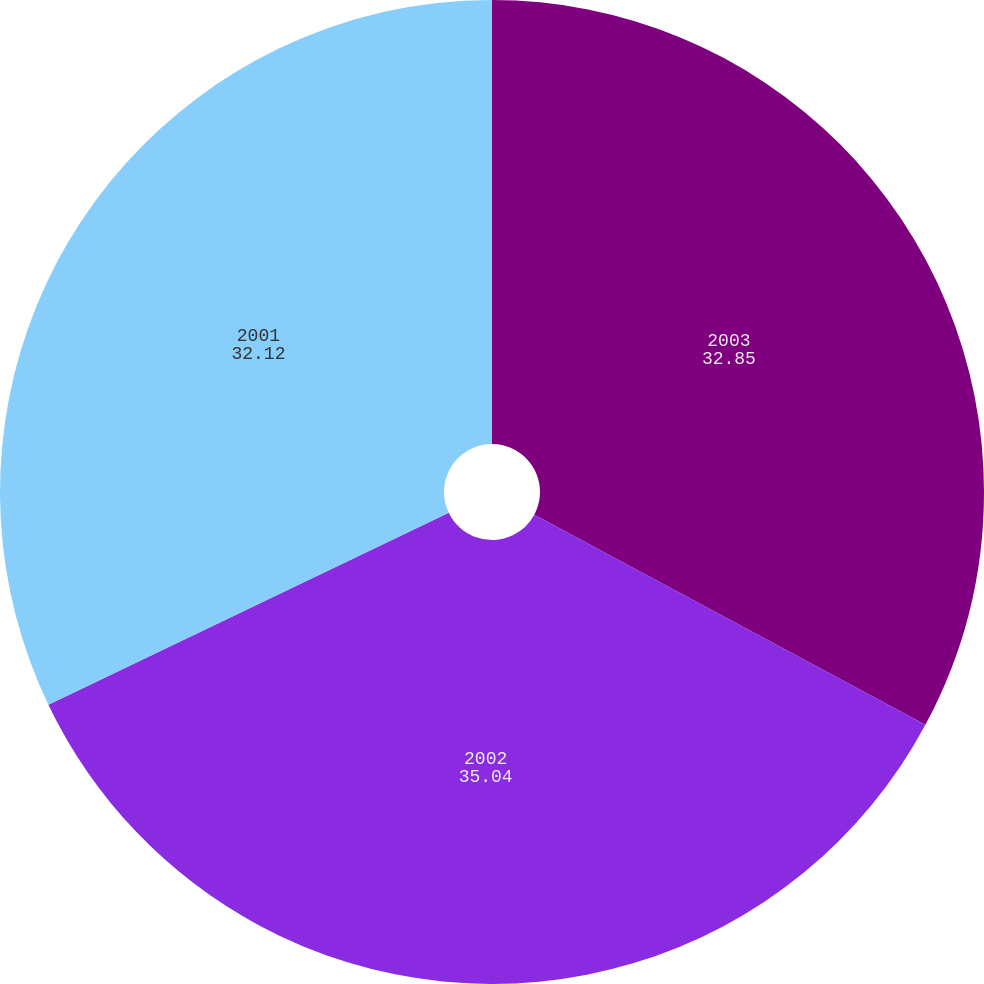<chart> <loc_0><loc_0><loc_500><loc_500><pie_chart><fcel>2003<fcel>2002<fcel>2001<nl><fcel>32.85%<fcel>35.04%<fcel>32.12%<nl></chart> 